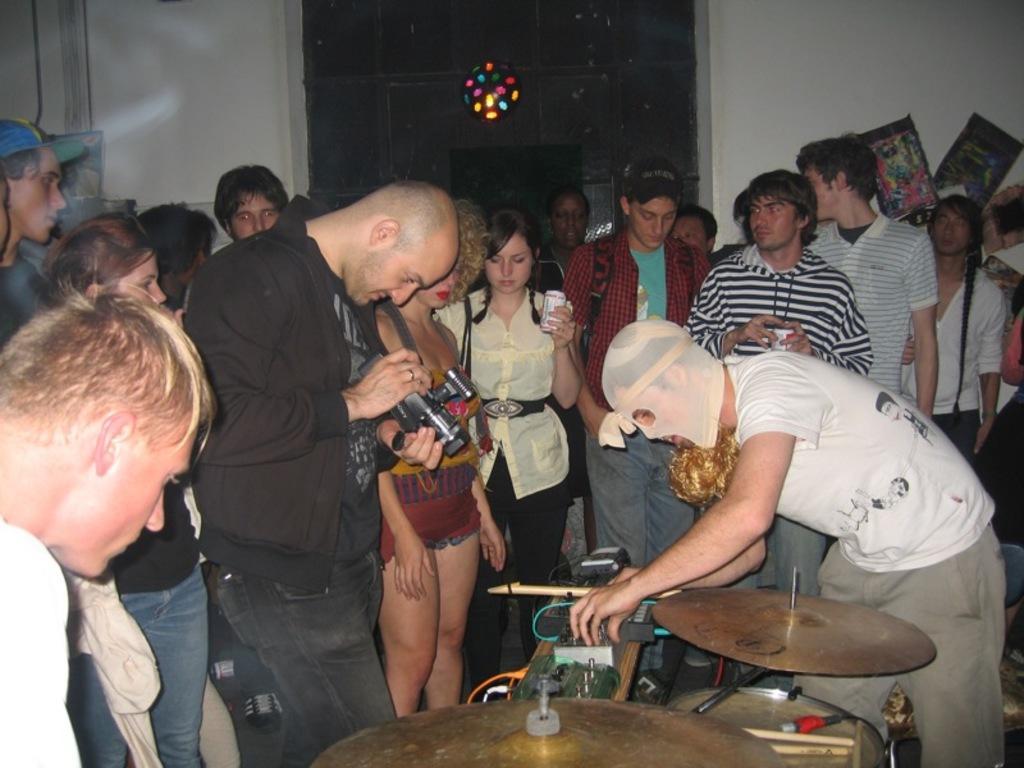In one or two sentences, can you explain what this image depicts? There are group of people standing and this man holding a camera,in front of this man we can see musical instrument and this man wore mask. In the background we can see posts on a wall and glass. 